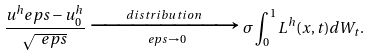<formula> <loc_0><loc_0><loc_500><loc_500>\frac { u ^ { h } _ { \ } e p s - u ^ { h } _ { 0 } } { \sqrt { \ e p s } } \xrightarrow [ \ e p s \to 0 ] { d i s t r i b u t i o n } \sigma \int _ { 0 } ^ { 1 } L ^ { h } ( x , t ) d W _ { t } .</formula> 